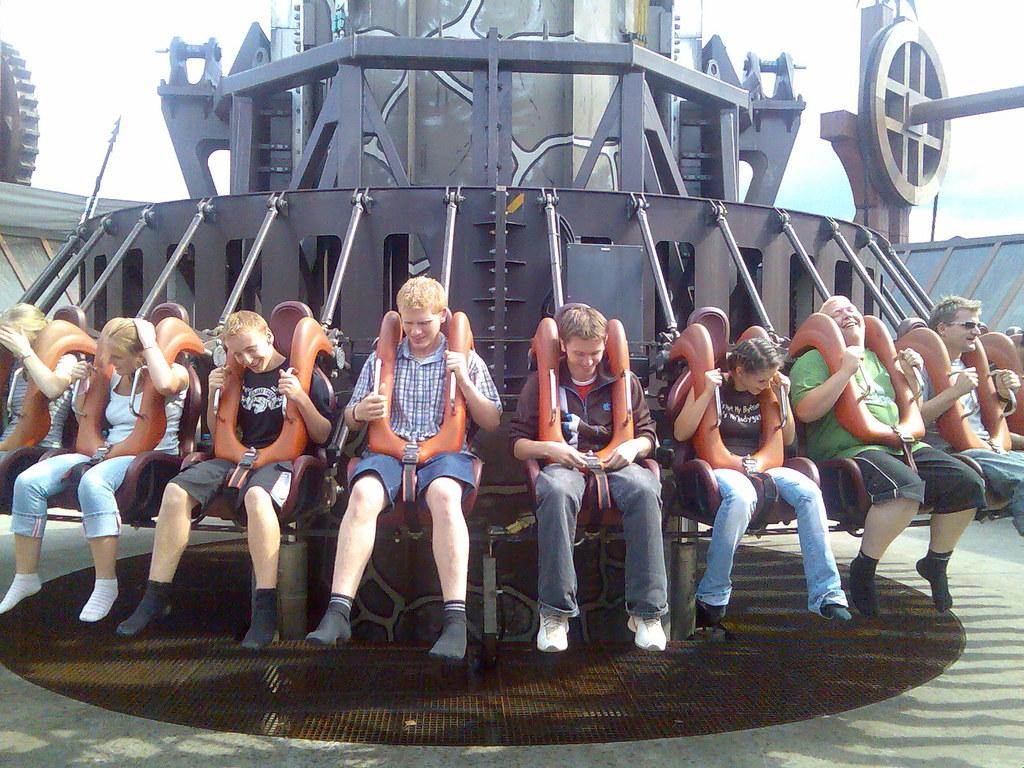What are the people in the image doing? The people in the image are sitting on a ride. What can be seen in the sky in the image? The sky is visible at the top of the image. What type of bean is growing on the ride in the image? There are no beans present in the image; the people are sitting on a ride. What is the moon's position in the image? The moon is not visible in the image; only the sky is visible. 